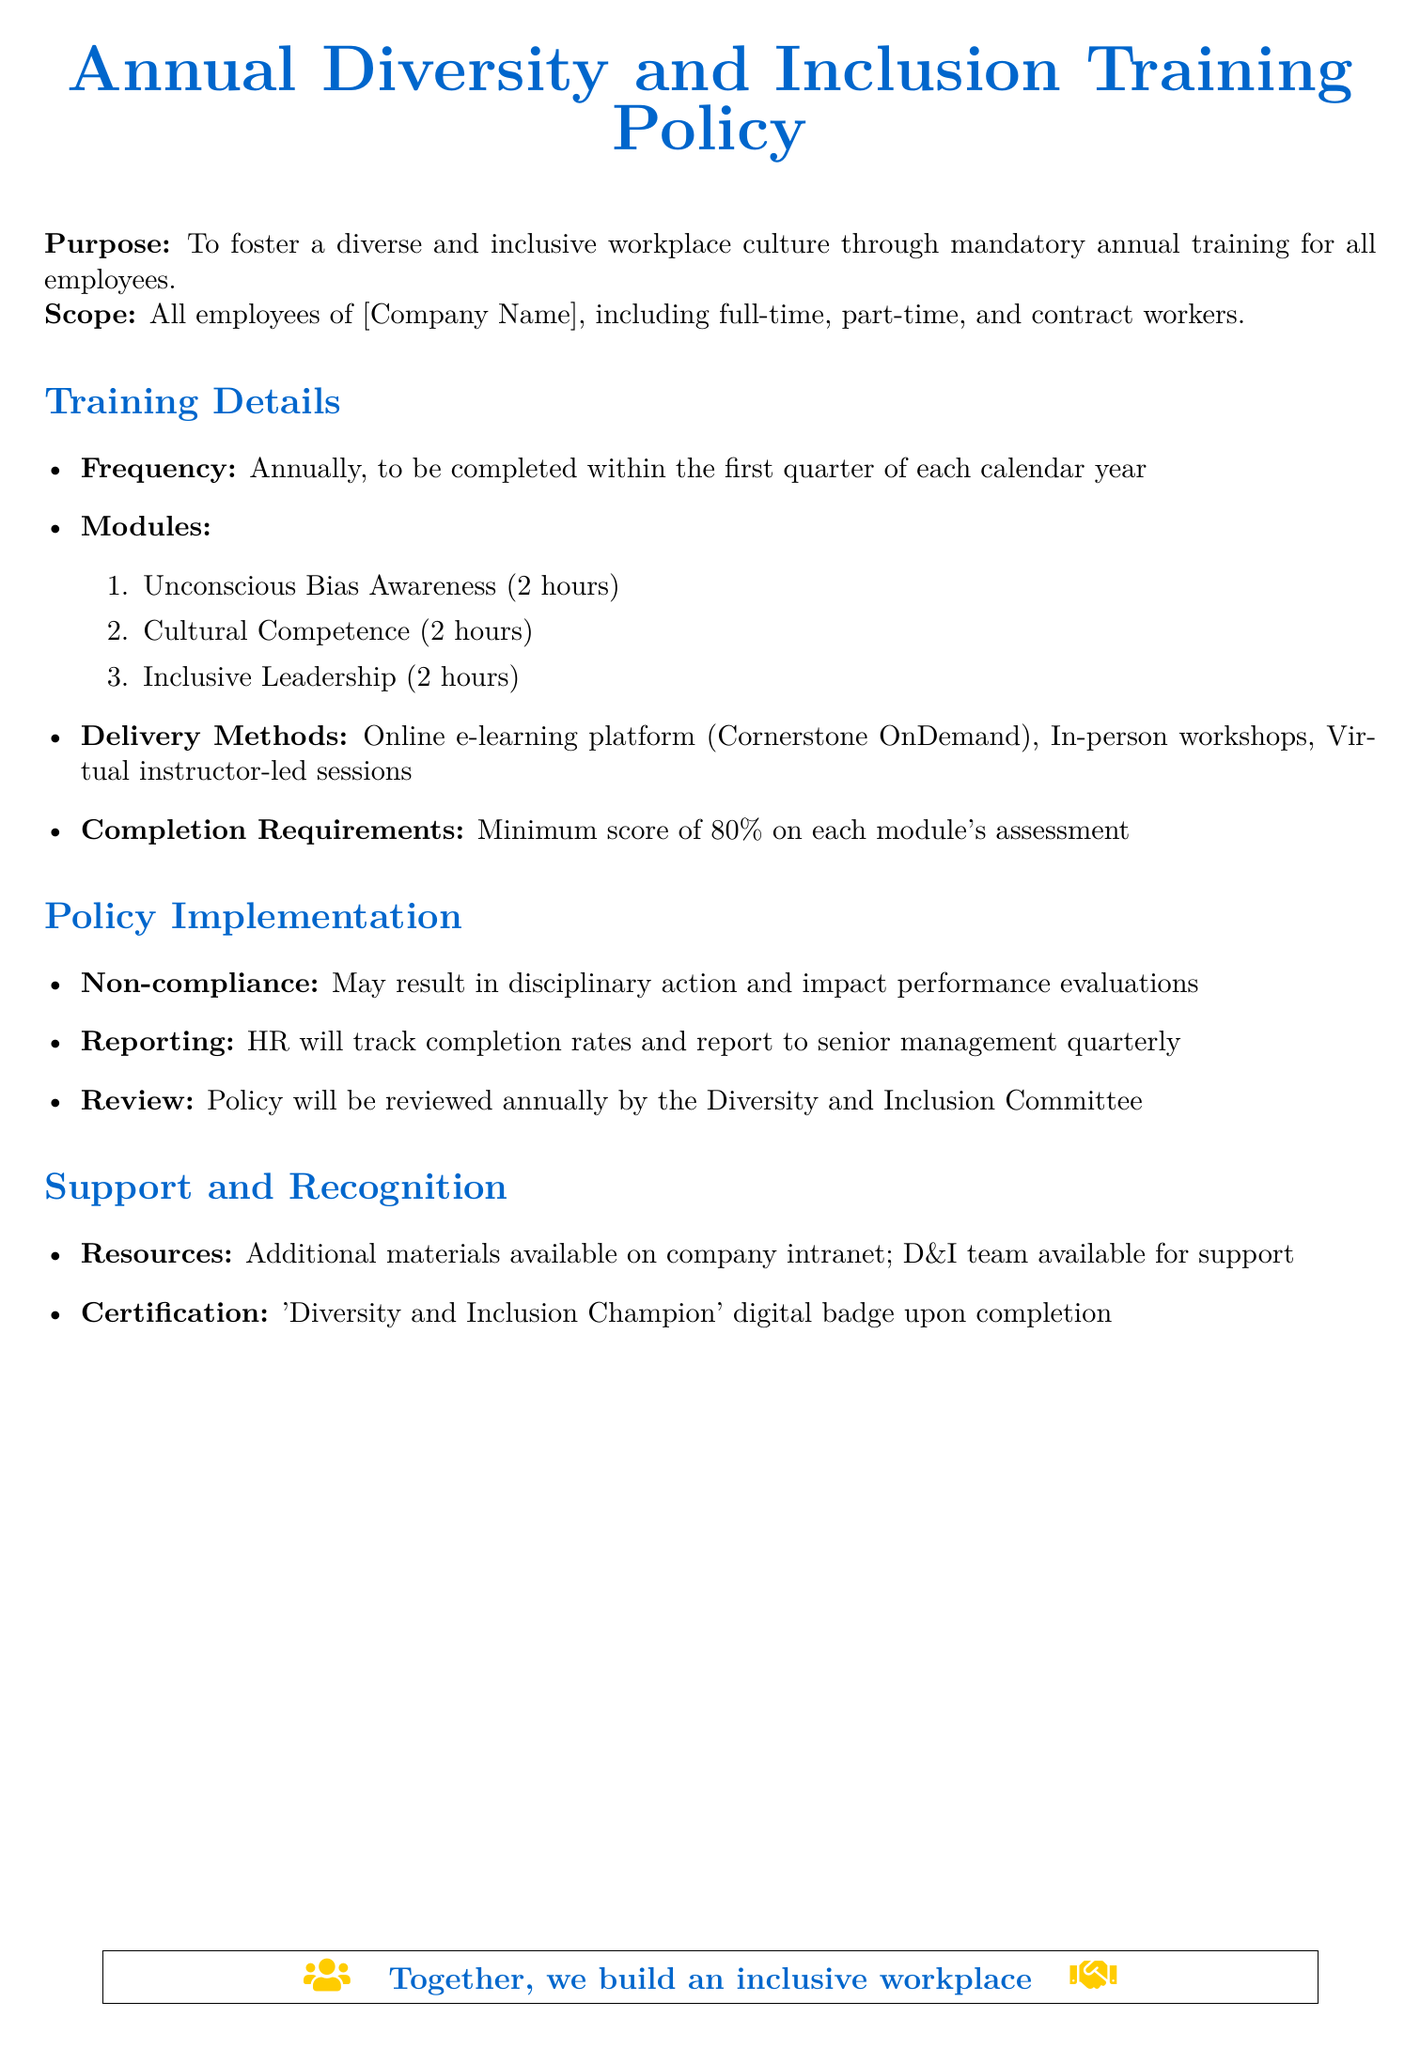What is the purpose of the policy? The purpose of the policy is stated as the aim to foster a diverse and inclusive workplace culture through mandatory annual training.
Answer: To foster a diverse and inclusive workplace culture Who is required to undergo this training? The scope of the training policy includes all employees of the company, which encompasses full-time, part-time, and contract workers.
Answer: All employees of [Company Name] How frequently is the training to be completed? The training frequency is specified as once a year, and it should be completed within the first quarter of each calendar year.
Answer: Annually What is the minimum passing score on each module's assessment? The document mentions that a minimum score of 80% is required to pass each module's assessment.
Answer: 80% What are the three training modules included in the policy? The modules listed in the policy are Unconscious Bias Awareness, Cultural Competence, and Inclusive Leadership.
Answer: Unconscious Bias Awareness, Cultural Competence, Inclusive Leadership What is the consequence for non-compliance with the training? The policy states that non-compliance may result in disciplinary action and could impact performance evaluations.
Answer: Disciplinary action Which team provides support and additional resources? The document mentions the D&I (Diversity and Inclusion) team as the group available for support and resources.
Answer: D&I team What certification is awarded upon completion of the training? The policy outlines that a 'Diversity and Inclusion Champion' digital badge will be awarded when the training is completed.
Answer: 'Diversity and Inclusion Champion' digital badge 